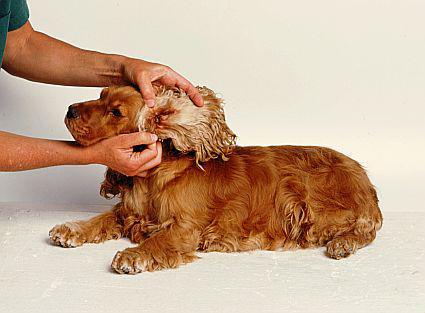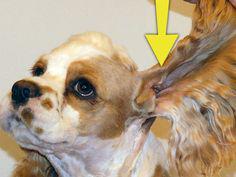The first image is the image on the left, the second image is the image on the right. For the images shown, is this caption "Human hands can be seen holding the dog's ear in one image." true? Answer yes or no. Yes. 